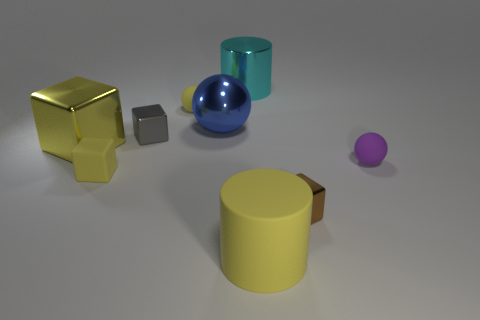Subtract all brown cubes. How many cubes are left? 3 Subtract all rubber cubes. How many cubes are left? 3 Subtract 1 balls. How many balls are left? 2 Add 1 large blue things. How many objects exist? 10 Subtract all cylinders. How many objects are left? 7 Subtract all purple cubes. Subtract all yellow cylinders. How many cubes are left? 4 Subtract 1 yellow balls. How many objects are left? 8 Subtract all tiny things. Subtract all matte cubes. How many objects are left? 3 Add 8 yellow matte cylinders. How many yellow matte cylinders are left? 9 Add 1 large yellow cylinders. How many large yellow cylinders exist? 2 